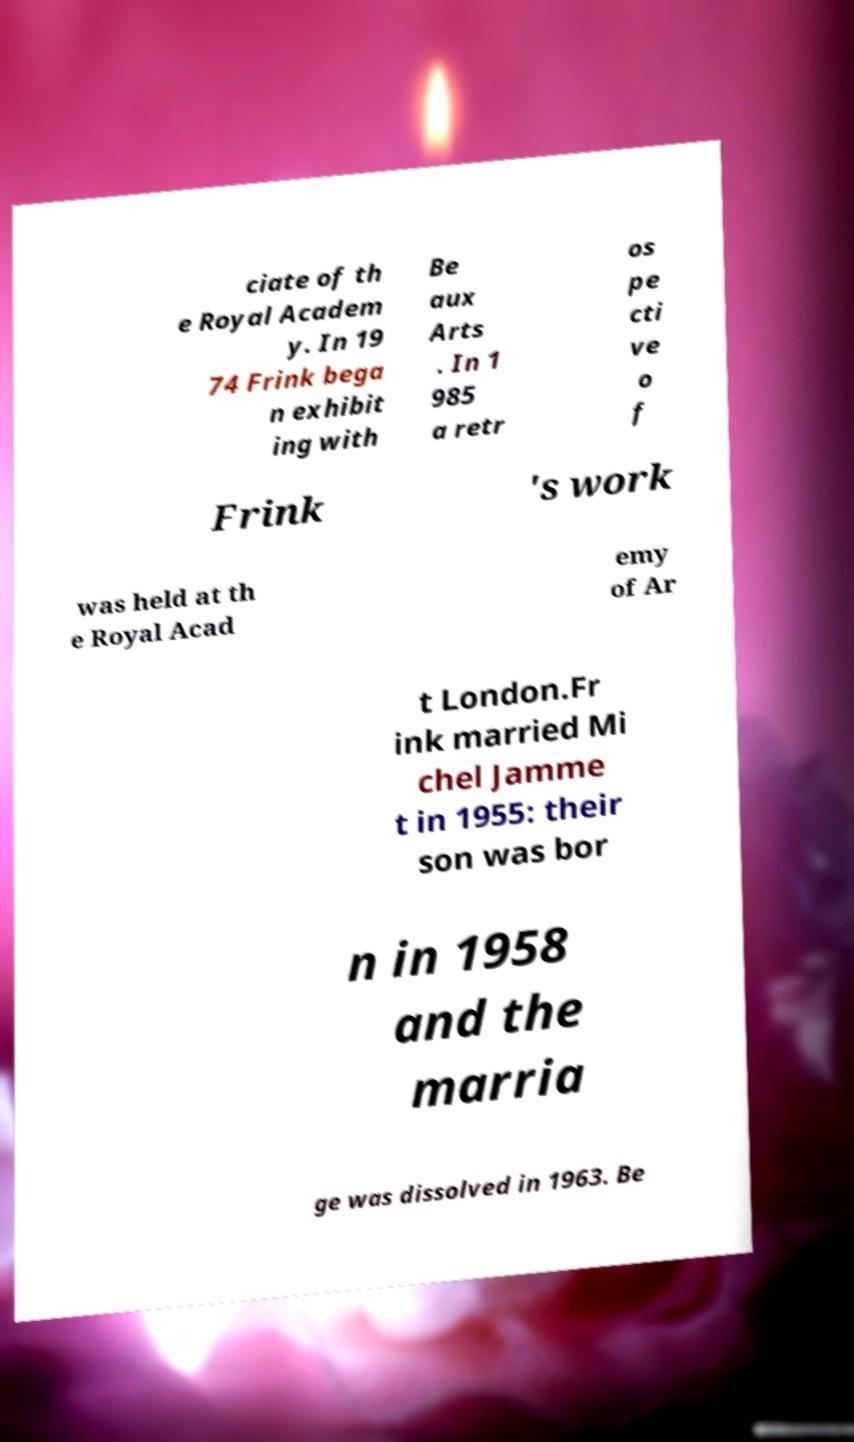Could you assist in decoding the text presented in this image and type it out clearly? ciate of th e Royal Academ y. In 19 74 Frink bega n exhibit ing with Be aux Arts . In 1 985 a retr os pe cti ve o f Frink 's work was held at th e Royal Acad emy of Ar t London.Fr ink married Mi chel Jamme t in 1955: their son was bor n in 1958 and the marria ge was dissolved in 1963. Be 